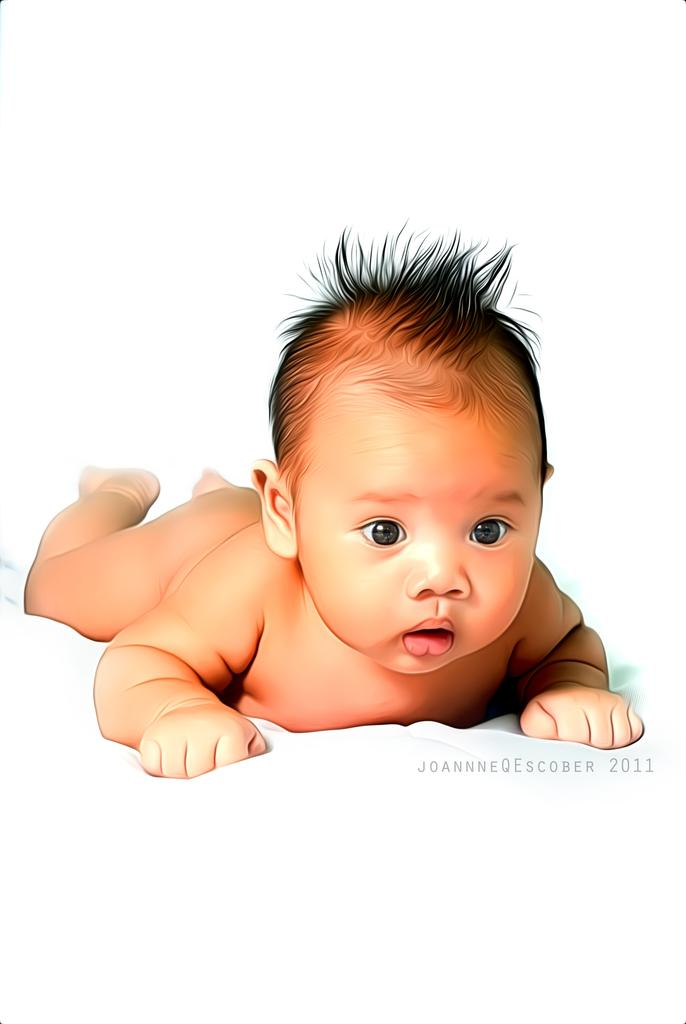What is the main subject of the image? The main subject of the image is a small kid. What is the kid doing in the image? The kid is laying on the floor. What type of kick can be seen in the image? There is no kick present in the image; it features a small kid laying on the floor. What kind of tramp is visible in the image? There is no tramp present in the image. 